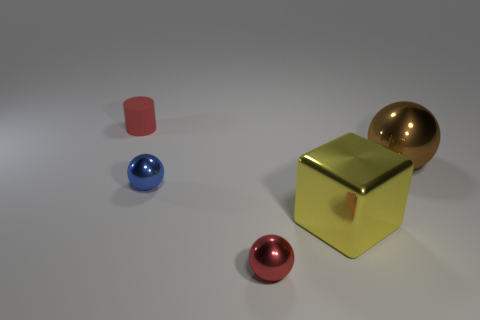Add 5 small metal objects. How many objects exist? 10 Subtract all spheres. How many objects are left? 2 Subtract 0 brown cylinders. How many objects are left? 5 Subtract all small blue metallic things. Subtract all big cyan rubber things. How many objects are left? 4 Add 5 red matte things. How many red matte things are left? 6 Add 1 cylinders. How many cylinders exist? 2 